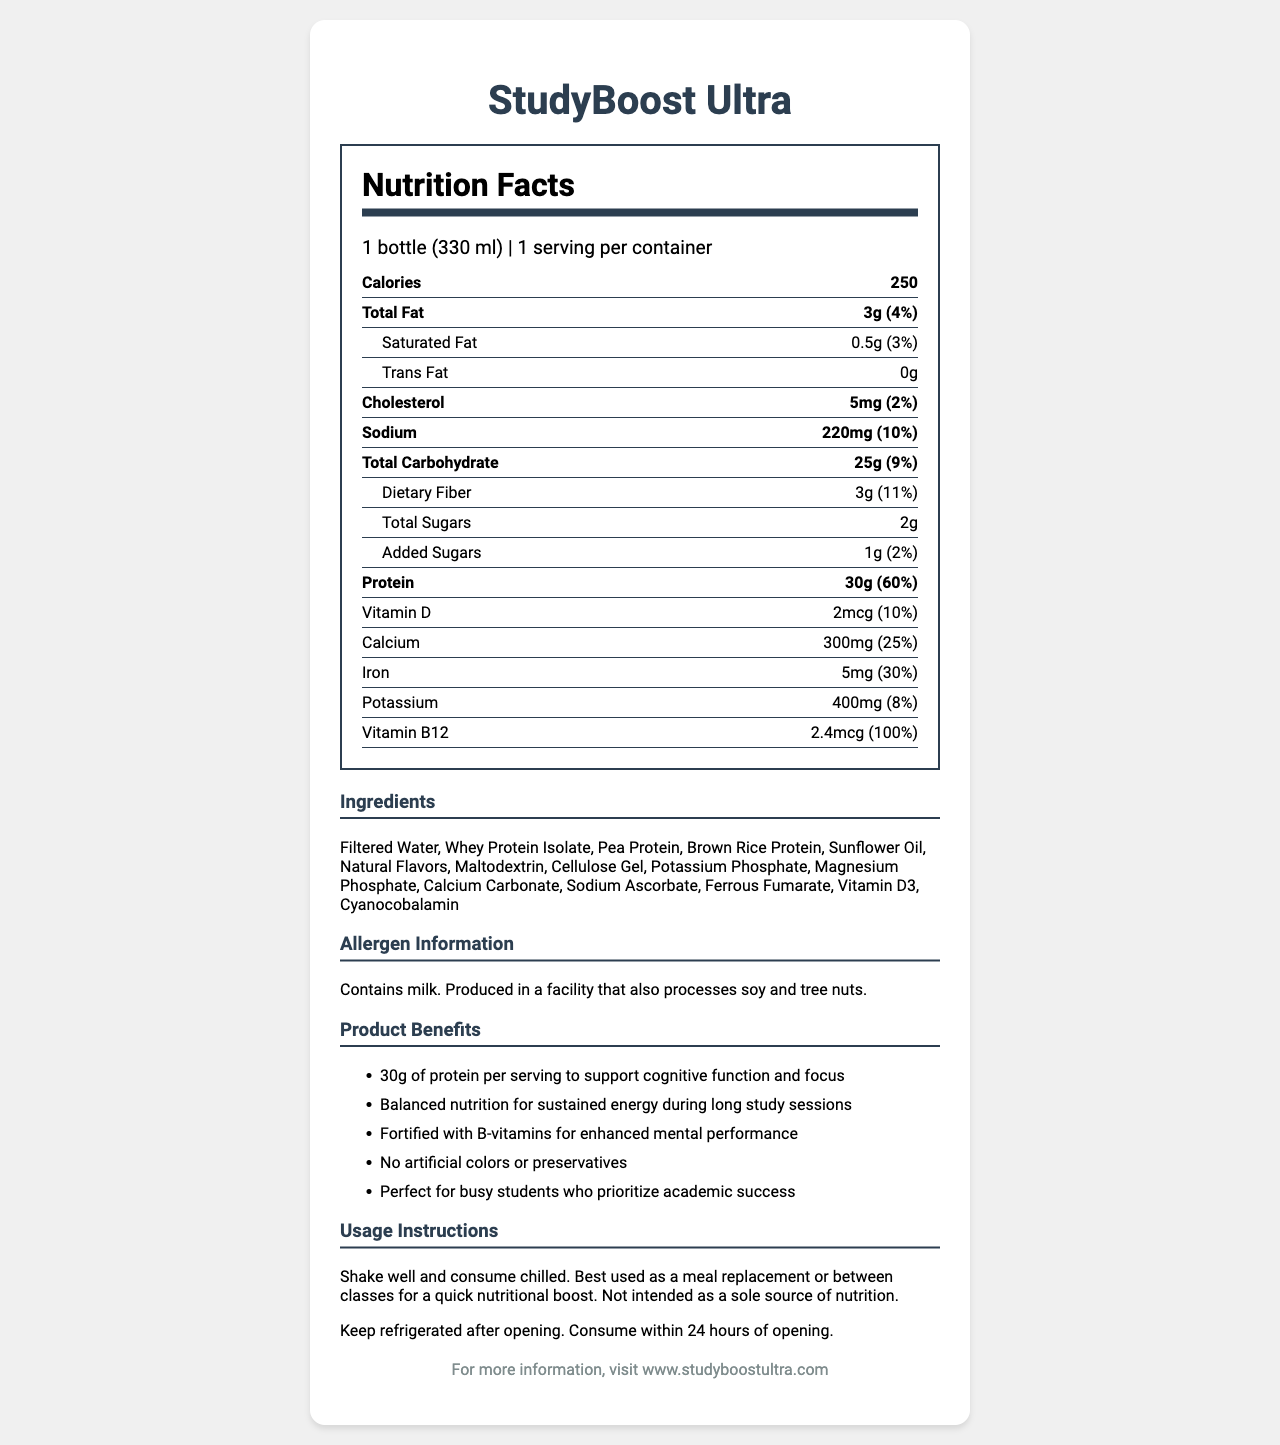what is the serving size of StudyBoost Ultra? The serving size is mentioned at the top of the nutrition label as "1 bottle (330 ml)".
Answer: 1 bottle (330 ml) what is the total amount of protein in StudyBoost Ultra? The total amount of protein is listed in the nutrition facts section as "Protein 30g".
Answer: 30g how much calcium is there in one serving of StudyBoost Ultra? The amount of calcium per serving is provided in the nutrition label under the vitamins and minerals section as "Calcium 300mg".
Answer: 300mg what is the percentage daily value of iron in StudyBoost Ultra? The percentage daily value of iron is listed in the nutrition facts section as "Iron 5mg (30%)".
Answer: 30% how much added sugar does StudyBoost Ultra contain? The nutrition facts section indicates the amount of added sugars as "Added Sugars 1g".
Answer: 1g what are the usage instructions for StudyBoost Ultra? A. Consume warm B. Shake well and consume chilled C. Do not shake The usage instructions provided in the document state "Shake well and consume chilled."
Answer: B what is the total carbohydrate content in StudyBoost Ultra? The nutrition facts section shows "Total Carbohydrate 25g".
Answer: 25g what are the allergens present in StudyBoost Ultra? A. Peanuts B. Gluten C. Milk The allergen information in the document states "Contains milk."
Answer: C does StudyBoost Ultra contain any artificial colors or preservatives? The marketing claims mention "No artificial colors or preservatives".
Answer: No what is the main purpose of StudyBoost Ultra as described in the document? The marketing claims emphasize that StudyBoost Ultra is designed to support cognitive function and provide sustained energy for academic success.
Answer: To provide balanced nutrition and support cognitive function for busy students how much sodium does StudyBoost Ultra contain? The sodium content is listed in the nutrition facts section as "Sodium 220mg".
Answer: 220mg can StudyBoost Ultra be consumed as the sole source of nutrition? The usage instructions clarify that it is "Not intended as a sole source of nutrition."
Answer: No how many calories does one bottle of StudyBoost Ultra provide? The nutrition facts section mentions "Calories 250."
Answer: 250 what is the main ingredient in StudyBoost Ultra? The ingredients list shows that the first ingredient is "Filtered Water".
Answer: Filtered Water is StudyBoost Ultra fortified with B-vitamins? The marketing claims state that it is "Fortified with B-vitamins for enhanced mental performance."
Answer: Yes what percentage of the daily value of Vitamin B12 does StudyBoost Ultra provide? The nutrition facts section indicates "Vitamin B12 2.4mcg (100%)".
Answer: 100% what is the most prominent marketing claim of StudyBoost Ultra? One of the main marketing claims listed is "30g of protein per serving to support cognitive function and focus."
Answer: 30g of protein per serving to support cognitive function and focus what is the storage recommendation after opening StudyBoost Ultra? The usage instructions state "Keep refrigerated after opening. Consume within 24 hours of opening."
Answer: Keep refrigerated and consume within 24 hours what is the daily value percentage of dietary fiber in StudyBoost Ultra? The nutrition facts section lists the dietary fiber content as "Dietary Fiber 3g (11%)".
Answer: 11% who is the target audience for StudyBoost Ultra? The marketing claims describe the product as "Perfect for busy students who prioritize academic success."
Answer: Busy students who prioritize academic success how can one find more information about StudyBoost Ultra? The footer of the document states "For more information, visit www.studyboostultra.com."
Answer: Visit www.studyboostultra.com which of these ingredients is NOT listed in StudyBoost Ultra? A. Whey Protein Isolate B. Pea Protein C. Palm Oil The ingredients list includes "Whey Protein Isolate" and "Pea Protein" but does not mention "Palm Oil."
Answer: C what is the product name listed in the document? The product name is prominently displayed at the top of the document as "StudyBoost Ultra".
Answer: StudyBoost Ultra does StudyBoost Ultra contribute to the intake of Vitamin D? The nutrition facts section lists "Vitamin D 2mcg (10%)" indicating that it contains Vitamin D.
Answer: Yes how many servings are there per container of StudyBoost Ultra? The serving information states "1 serving per container".
Answer: 1 describe the entire document. The document is a detailed representation of the nutrition facts, ingredients, allergen information, marketing claims, usage instructions, and storage recommendations for StudyBoost Ultra, a meal replacement shake aimed at busy students. It highlights the nutritional content and benefits of the product to aid academic performance.
Answer: StudyBoost Ultra Nutrition Facts Label provides detailed nutritional information for a high-protein meal replacement shake designed for busy students. It highlights the serving size, calorie content, and percentages of daily values for various nutrients. The document includes ingredient and allergen information, marketing claims about the benefits of the product, usage instructions, and storage recommendations. It aims to support cognitive function and provide balanced nutrition for academic success. For more information, the brand website is provided. 